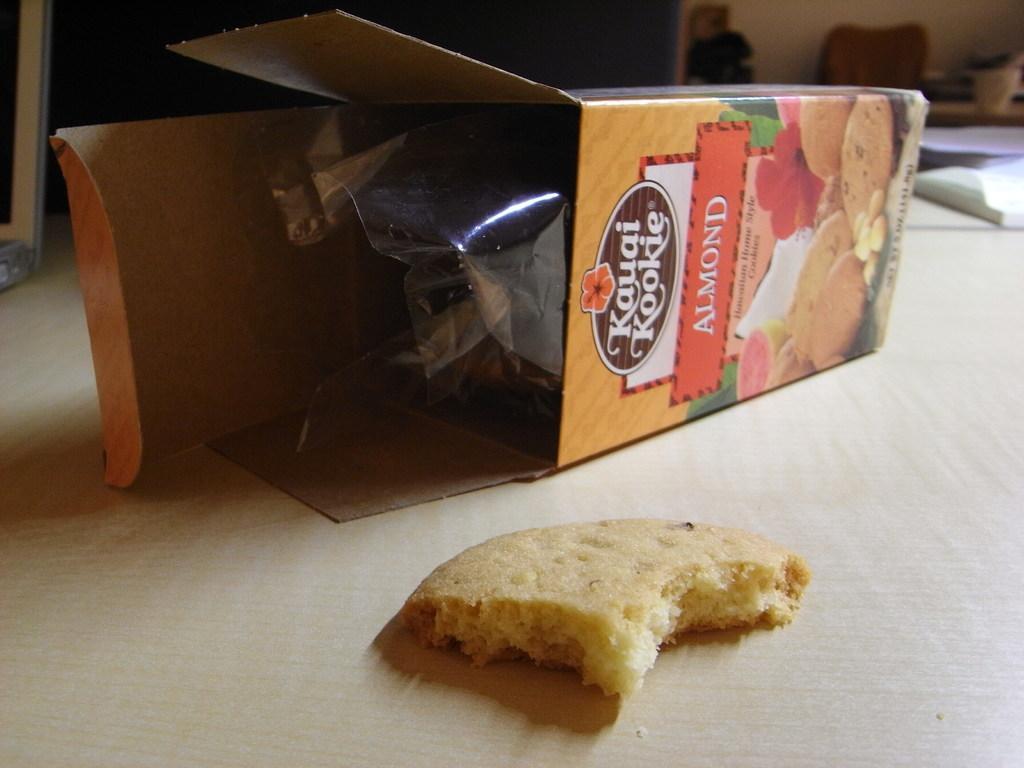How would you summarize this image in a sentence or two? In this picture we can see a carton with almond cookies kept on the table. 